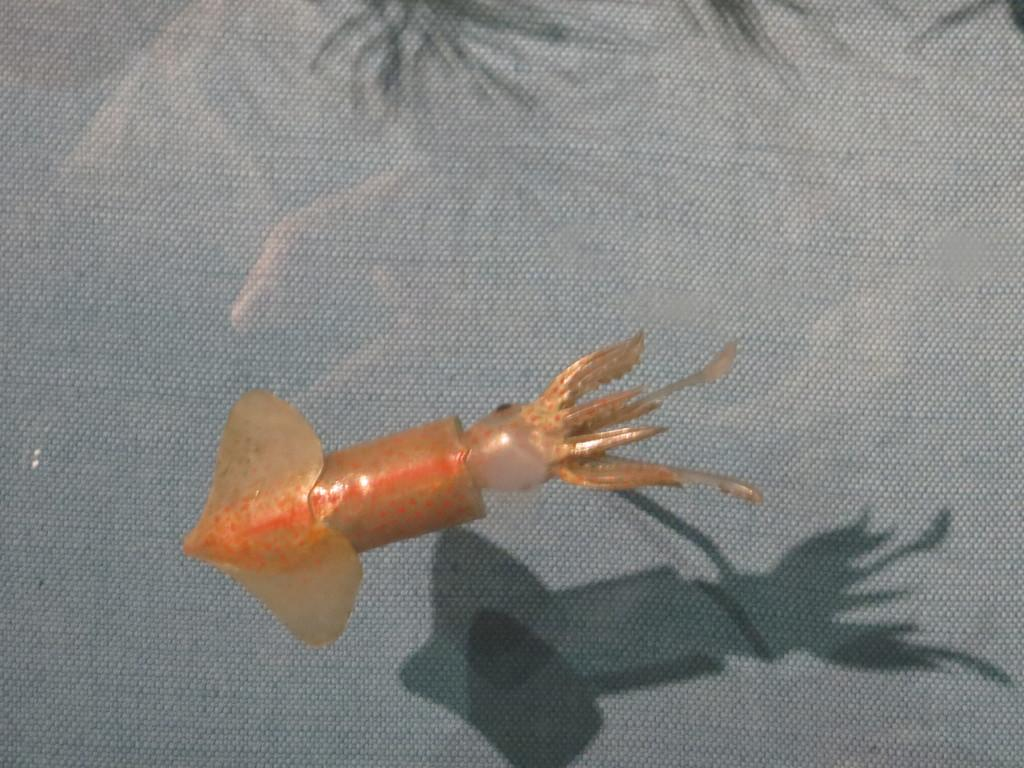What is located at the bottom of the image? There is an animal in the water at the bottom of the image. What can be seen in the background of the image? The background of the image is gray in color. What type of oatmeal is being served to the chickens in the image? There are no chickens or oatmeal present in the image; it features an animal in the water with a gray background. 